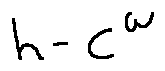Convert formula to latex. <formula><loc_0><loc_0><loc_500><loc_500>h - C ^ { w }</formula> 